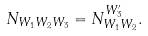Convert formula to latex. <formula><loc_0><loc_0><loc_500><loc_500>N _ { W _ { 1 } W _ { 2 } W _ { 3 } } = N _ { W _ { 1 } W _ { 2 } } ^ { W _ { 3 } ^ { \prime } } .</formula> 